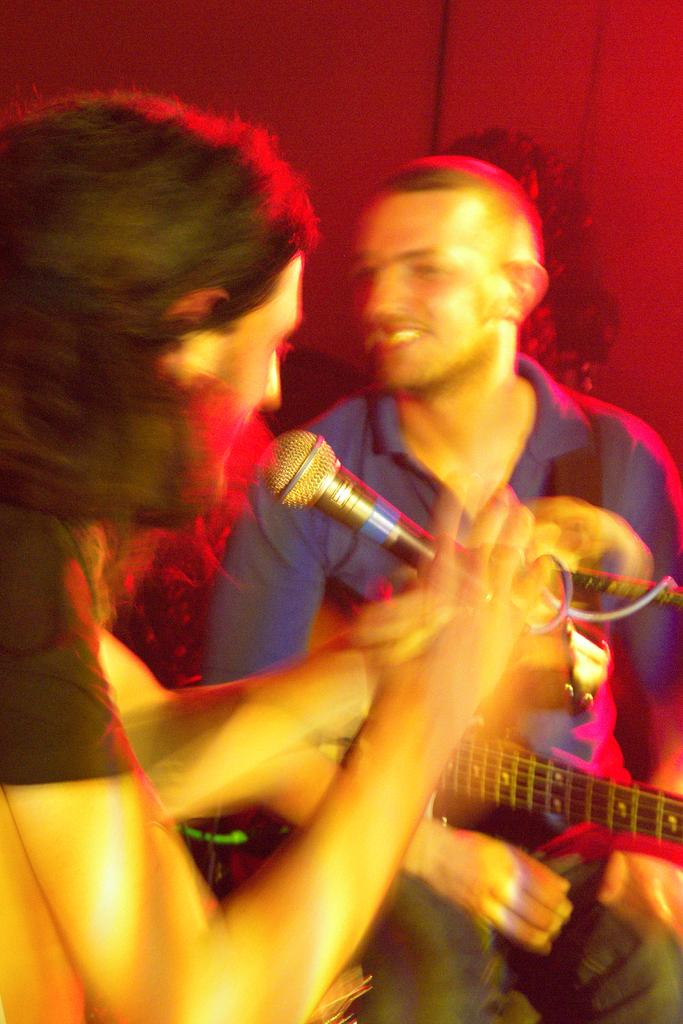What is the man in the foreground of the image holding? The man in the foreground is holding a mic. Can you describe the man in the background of the image? The man in the background is sitting and holding a guitar. What color is the wall visible in the image? The wall in the image is red. How many people are present in the image? There are two people in the image. What type of sail can be seen in the background of the image? There is no sail present in the image; it features two men, one holding a mic and the other holding a guitar, in front of a red wall. 